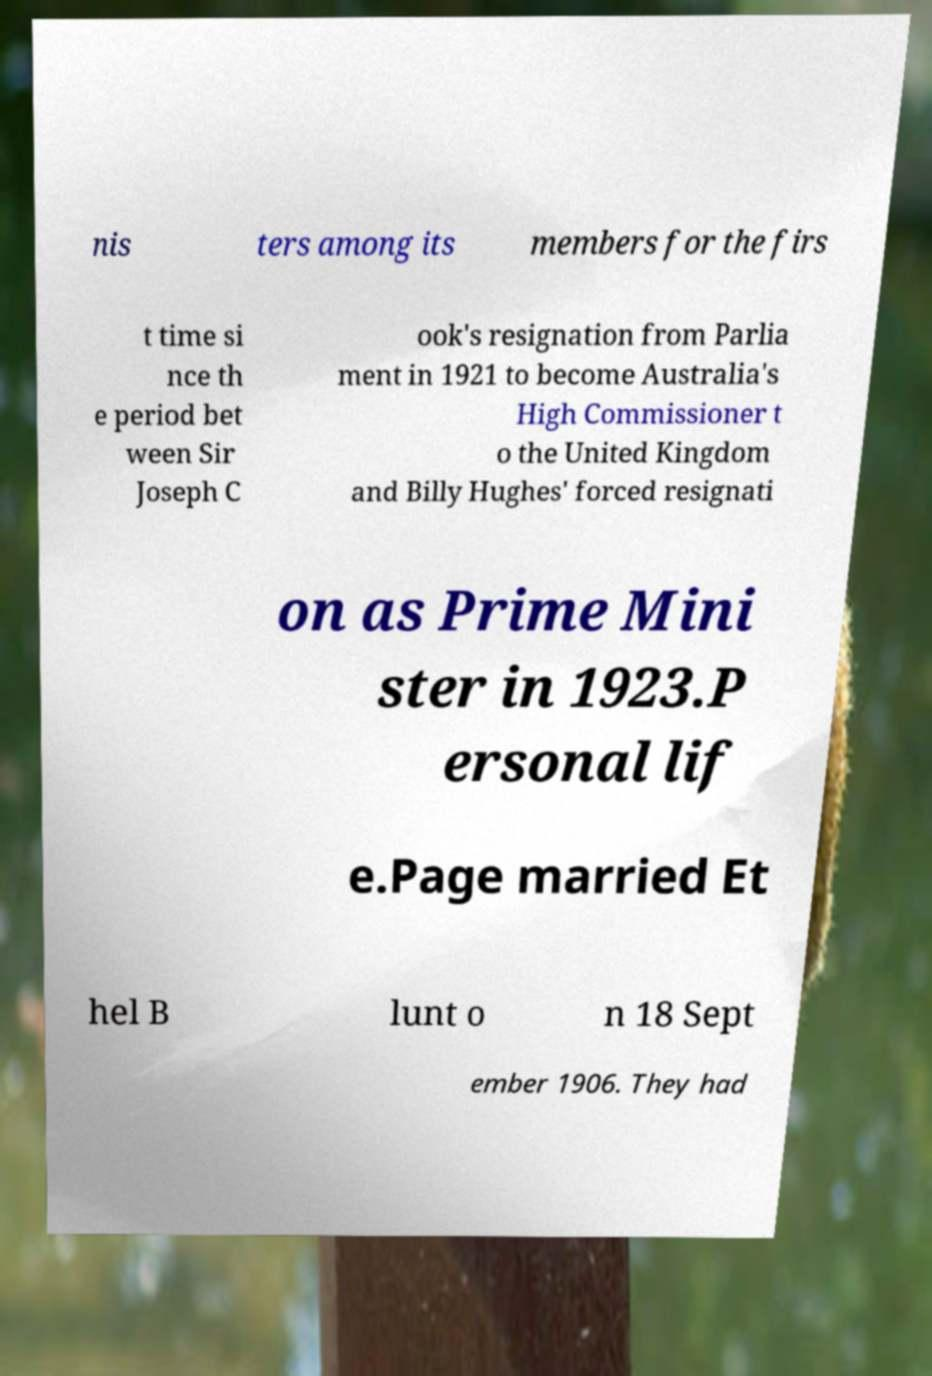I need the written content from this picture converted into text. Can you do that? nis ters among its members for the firs t time si nce th e period bet ween Sir Joseph C ook's resignation from Parlia ment in 1921 to become Australia's High Commissioner t o the United Kingdom and Billy Hughes' forced resignati on as Prime Mini ster in 1923.P ersonal lif e.Page married Et hel B lunt o n 18 Sept ember 1906. They had 